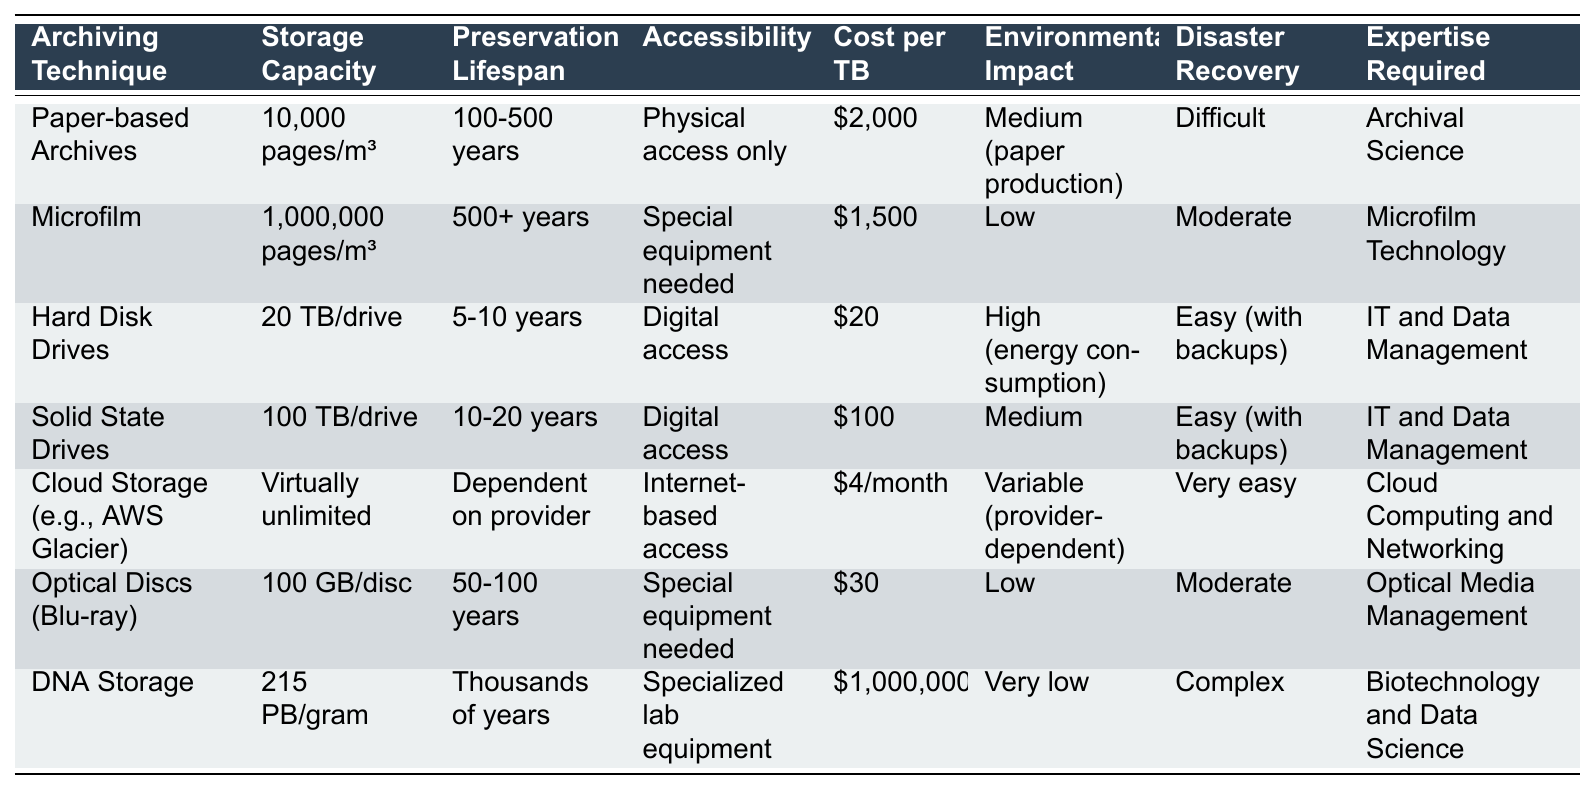What is the storage capacity of DNA Storage? The storage capacity of DNA Storage is listed as 215 PB/gram in the table.
Answer: 215 PB/gram Which archiving technique has the lowest cost per TB? The table shows that Hard Disk Drives have the lowest cost per TB at $20.
Answer: $20 Is the preservation lifespan of Microfilm greater than that of Solid State Drives? Microfilm has a preservation lifespan of 500+ years, while Solid State Drives have a lifespan of 10-20 years, therefore, yes, Microfilm's lifespan is greater.
Answer: Yes What is the average cost per TB of the digital archiving techniques (Hard Disk Drives, Solid State Drives, Cloud Storage, Optical Discs)? The cost per TB for each is as follows: Hard Disk Drives: $20, Solid State Drives: $100, Cloud Storage: $4/month (approximately $48/month over a year), and Optical Discs: $30. Summing them gives $20 + $100 + $48 + $30 = $198 and averaging by dividing by 4 results in $49.50.
Answer: $49.50 Which archiving technique has virtually unlimited storage capacity and what is its corresponding expertise requirement? The Cloud Storage technique has virtually unlimited storage capacity, and the required expertise is in Cloud Computing and Networking.
Answer: Cloud Storage; Cloud Computing and Networking What is the environmental impact of Hard Disk Drives compared to Microfilm? The table indicates that Hard Disk Drives have a high environmental impact due to energy consumption, whereas Microfilm has a low environmental impact. Thus, Hard Disk Drives are worse off than Microfilm.
Answer: Hard Disk Drives have a higher impact Determine the difference in preservation lifespan between Cloud Storage and Paper-based Archives? Cloud Storage's preservation lifespan is dependent on the provider; Paper-based Archives have a lifespan of 100-500 years. Since Cloud Storage's lifespan isn't defined numerically and varies, we can't quantify a difference.
Answer: Not quantifiable Which archiving technique requires the most expertise and what is that expertise? The technique that requires the most expertise is DNA Storage, which requires Biotechnology and Data Science knowledge.
Answer: DNA Storage; Biotechnology and Data Science Is it true that Solid State Drives have better disaster recovery capabilities compared to Paper-based Archives? Solid State Drives offer easy disaster recovery with backups, while Paper-based Archives state that disaster recovery is difficult. Therefore, it is true.
Answer: Yes If you had all the archiving techniques listed, which one would last the shortest time before needing replacement? Hard Disk Drives last between 5 to 10 years, which is the shortest lifespan compared to others in the table.
Answer: Hard Disk Drives 